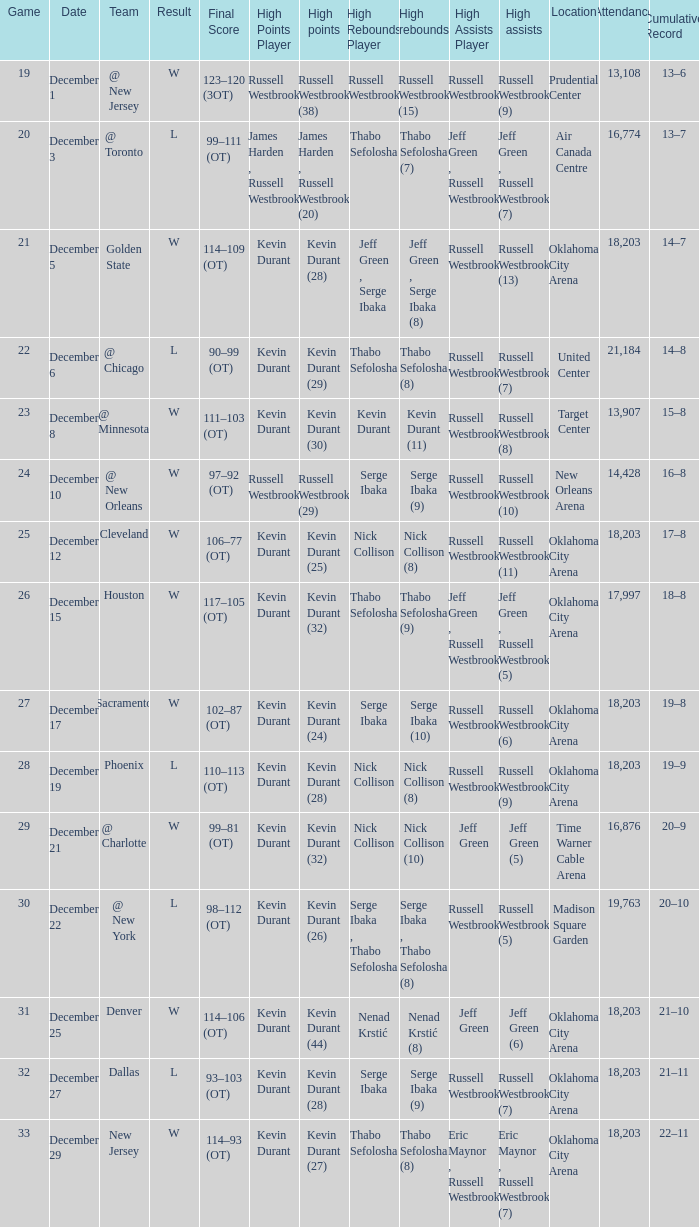What was the record on December 27? 21–11. 